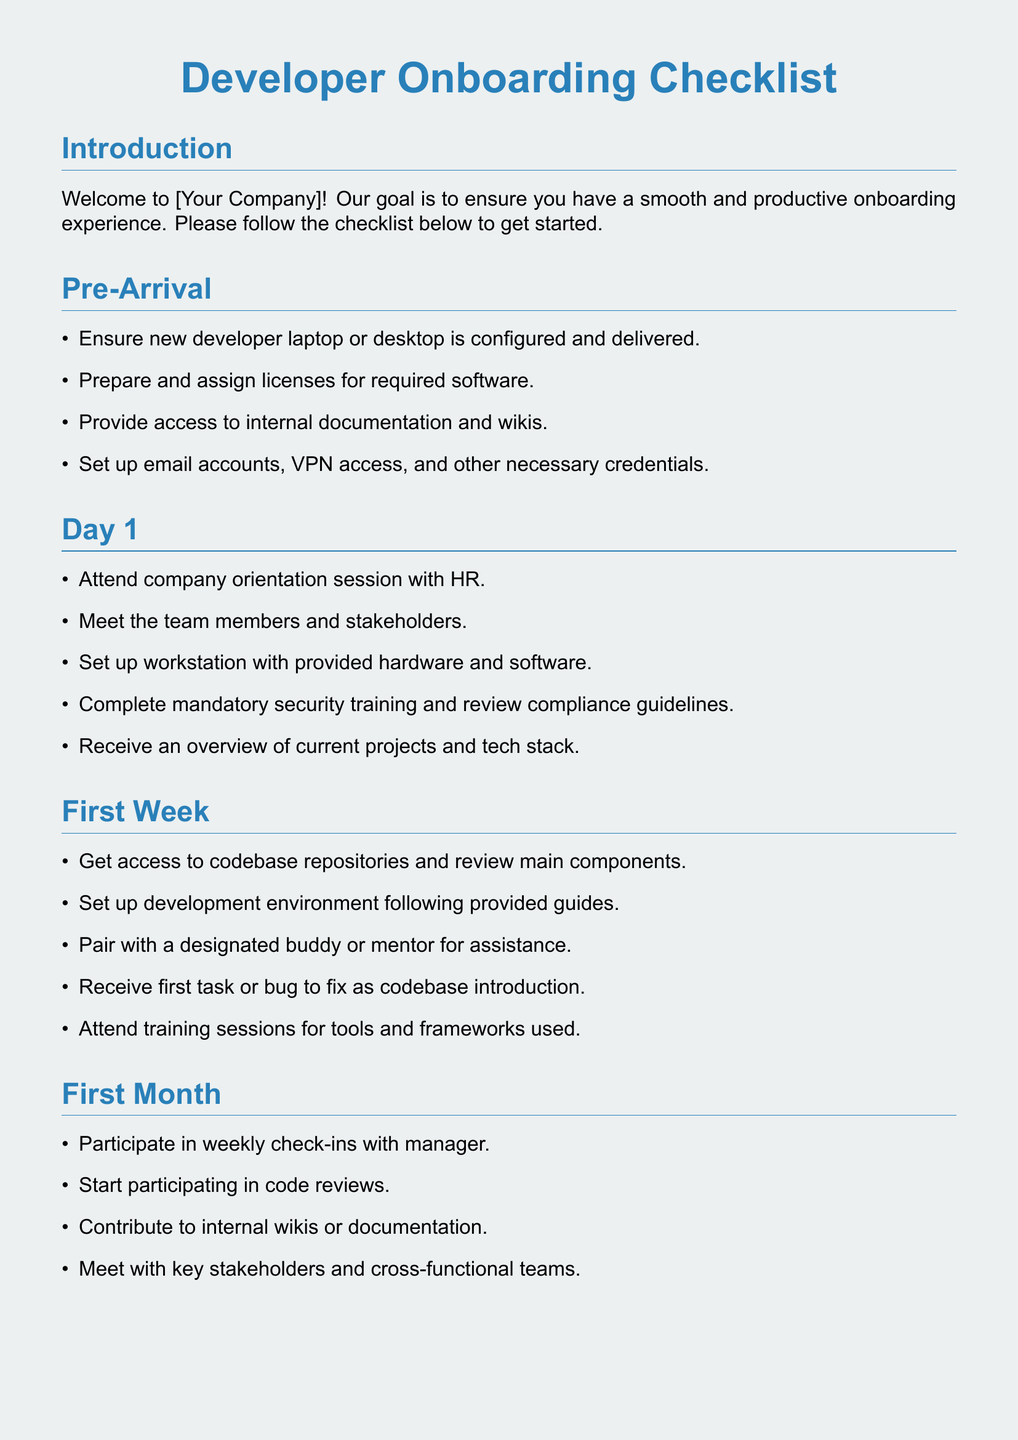What is the title of the checklist? The title of the checklist is stated at the beginning of the document.
Answer: Developer Onboarding Checklist How many sections are in the document? The document has five main sections detailing the onboarding process.
Answer: Five What is the first task listed under Pre-Arrival? The first task under Pre-Arrival is explicitly mentioned in the list.
Answer: Ensure new developer laptop or desktop is configured and delivered What is the focus of the First Month section? The First Month section focuses on the activities and integrations after the initial onboarding period.
Answer: Participate in weekly check-ins with manager How often should new developers meet with their manager during the First Three Months? The document mentions this frequency within the context of performance reviews.
Answer: Weekly What is one example of ongoing support listed? Ongoing support includes various resources mentioned as part of the ongoing process.
Answer: Continue using company-provided learning resources What does the checklist suggest for the first task on Day 1? The checklist provides a specific task for new hires on their first day.
Answer: Attend company orientation session with HR Who should new developers pair with during the First Week? The document specifically names the person type new developers should be paired with.
Answer: Designated buddy or mentor 